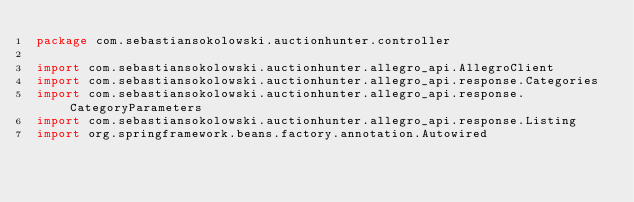<code> <loc_0><loc_0><loc_500><loc_500><_Kotlin_>package com.sebastiansokolowski.auctionhunter.controller

import com.sebastiansokolowski.auctionhunter.allegro_api.AllegroClient
import com.sebastiansokolowski.auctionhunter.allegro_api.response.Categories
import com.sebastiansokolowski.auctionhunter.allegro_api.response.CategoryParameters
import com.sebastiansokolowski.auctionhunter.allegro_api.response.Listing
import org.springframework.beans.factory.annotation.Autowired</code> 